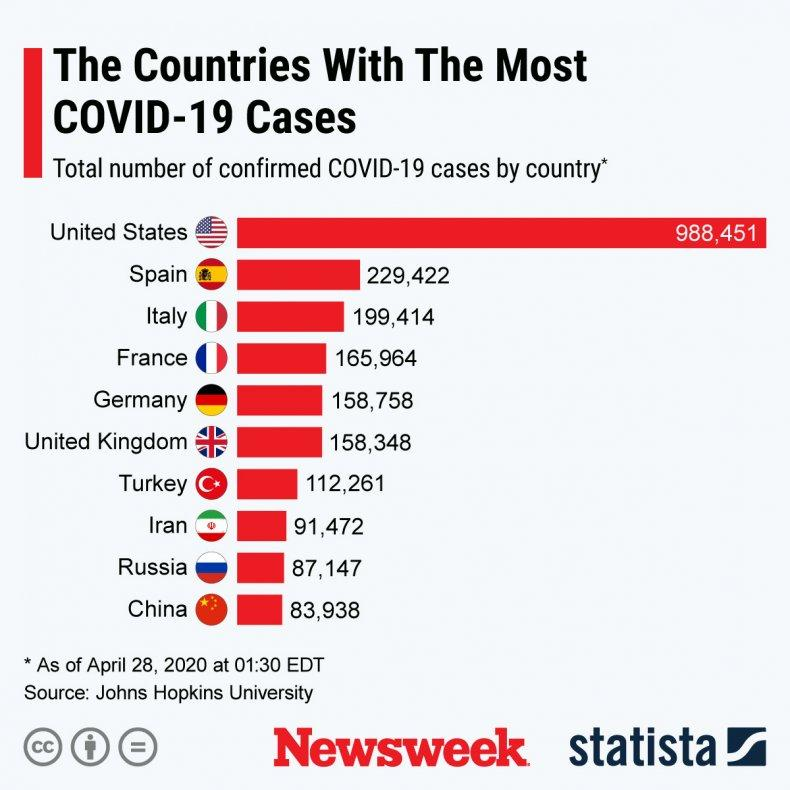Highlight a few significant elements in this photo. On April 28, 2020, Italy had the third highest number of confirmed Covid-19 cases, according to the most recent data available. As of April 28, 2020, it is confirmed that China has the least number of Covid-19 cases. As of April 28, 2020, the total number of confirmed Covid-19 cases in Germany was 158,758. According to the latest data available as of April 28, 2020, Russia has the second lowest number of confirmed Covid-19 cases. Spain has the second highest number of confirmed Covid-19 cases as of April 28, 2020. 